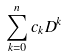Convert formula to latex. <formula><loc_0><loc_0><loc_500><loc_500>\sum _ { k = 0 } ^ { n } c _ { k } D ^ { k }</formula> 